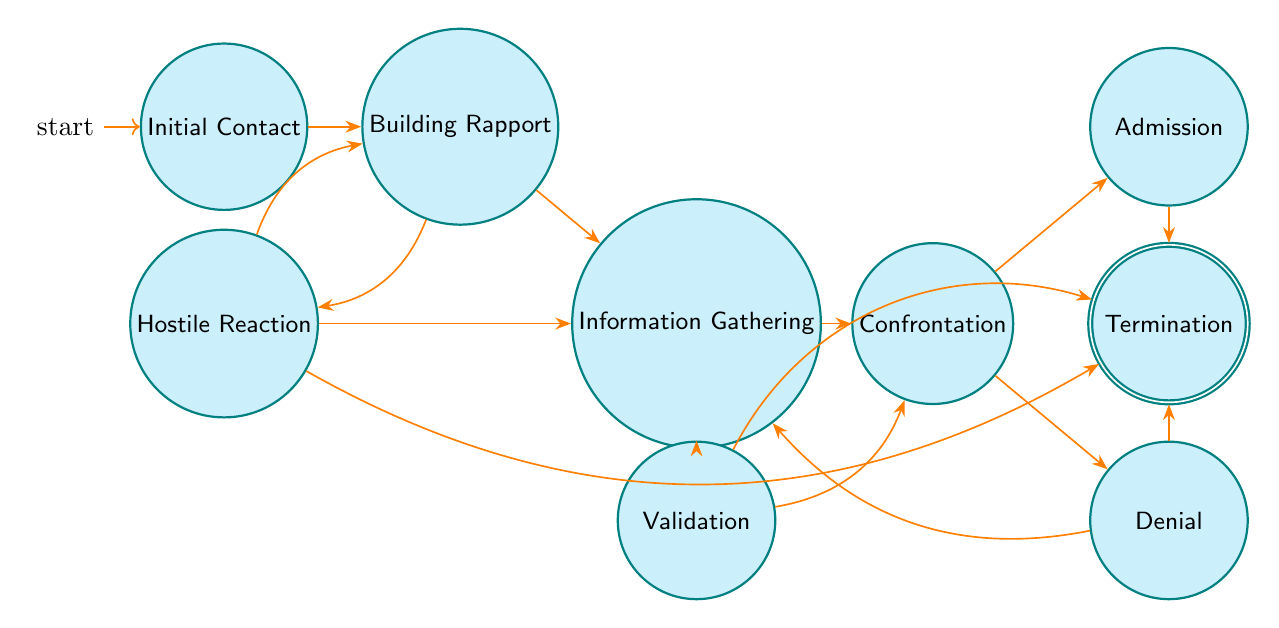What is the first state in the interrogation process? The diagram starts with the "Initial Contact" state, which is indicated as the first node in the flow. This state represents the beginning of the interrogation process where the suspect is informed of their rights.
Answer: Initial Contact How many states are there in total? By counting the distinct states illustrated in the diagram, we see there are nine states: Initial Contact, Building Rapport, Information Gathering, Hostile Reaction, Confrontation, Validation, Admission, Denial, and Termination.
Answer: Nine Which state leads to "Information Gathering"? The "Building Rapport" state transitions directly into "Information Gathering," as indicated by the arrow connecting these two nodes.
Answer: Building Rapport What happens after "Confrontation" if the suspect admits to involvement? Following the "Confrontation" state, if the suspect admits to involvement, the next state is "Admission," and then it leads to "Termination," indicating the end of the interrogation process.
Answer: Termination In which state does the suspect have a hostile reaction? The "Hostile Reaction" state is explicitly represented in the diagram and it indicates a phase where the suspect is uncooperative or hostile during interrogation.
Answer: Hostile Reaction How can the interrogation process be concluded? The interrogation can be concluded from multiple states: either through "Admission," "Denial," "Validation," or "Hostile Reaction." However, the "Termination" state signifies that the interrogation has definitively ended based on the preceding interactions.
Answer: Termination Which state can transition back to "Building Rapport"? The "Hostile Reaction" state has an option to transition back to "Building Rapport." This indicates that if the suspect responds hostilely, the interrogator may attempt to build rapport again.
Answer: Hostile Reaction How many transitions come from "Information Gathering"? The "Information Gathering" state has two outgoing transitions: one leading to "Confrontation" and the other leading to "Validation."
Answer: Two What is the relationship between "Denial" and "Information Gathering"? The diagram shows that the "Denial" state can transition back to "Information Gathering," indicating that if a suspect denies involvement, the interrogator can return to gather more information from the suspect.
Answer: Transition back 